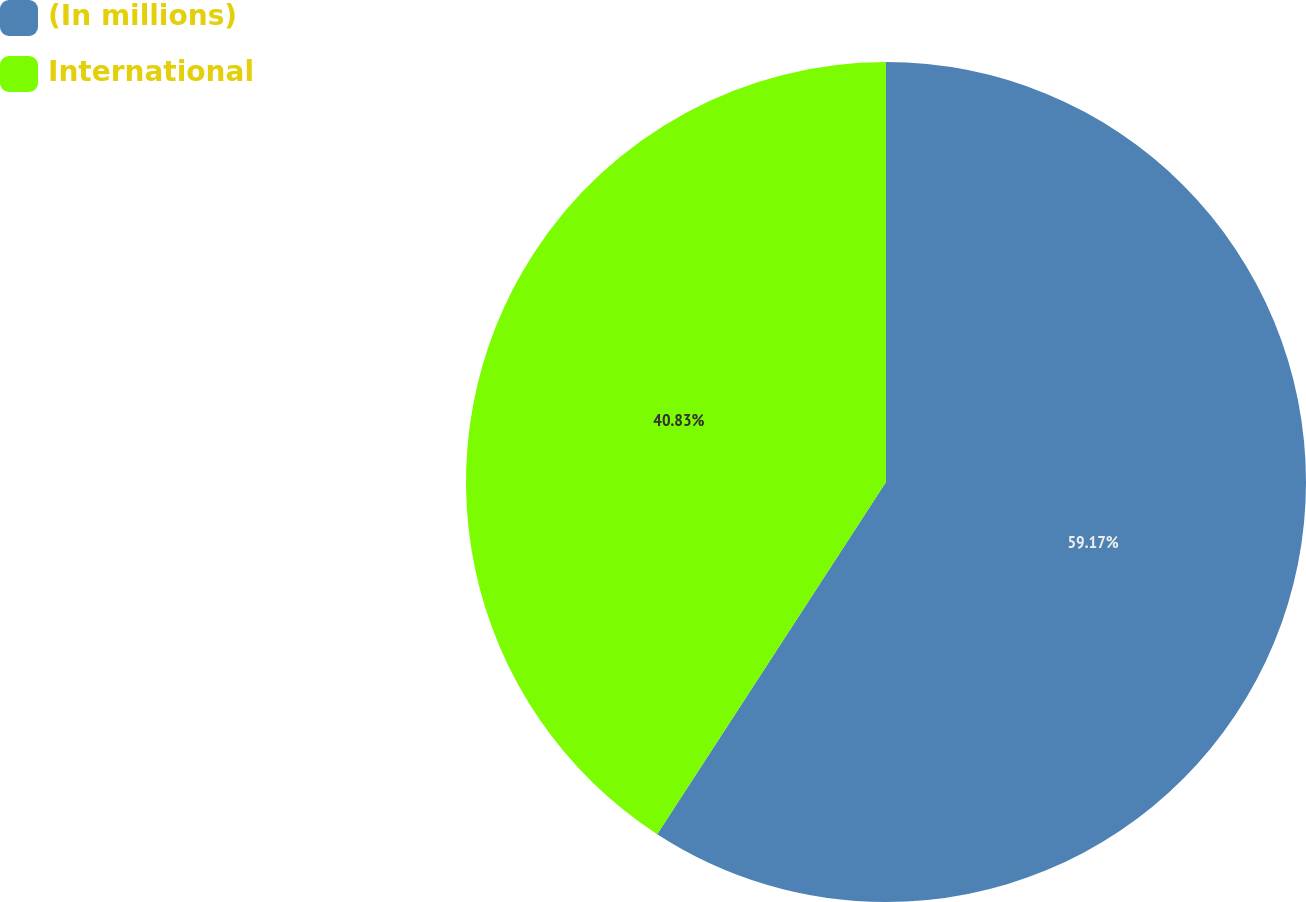Convert chart. <chart><loc_0><loc_0><loc_500><loc_500><pie_chart><fcel>(In millions)<fcel>International<nl><fcel>59.17%<fcel>40.83%<nl></chart> 